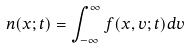<formula> <loc_0><loc_0><loc_500><loc_500>n ( x ; t ) = \int _ { - \infty } ^ { \infty } f ( x , v ; t ) d v</formula> 